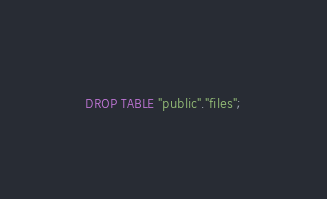Convert code to text. <code><loc_0><loc_0><loc_500><loc_500><_SQL_>DROP TABLE "public"."files";
</code> 